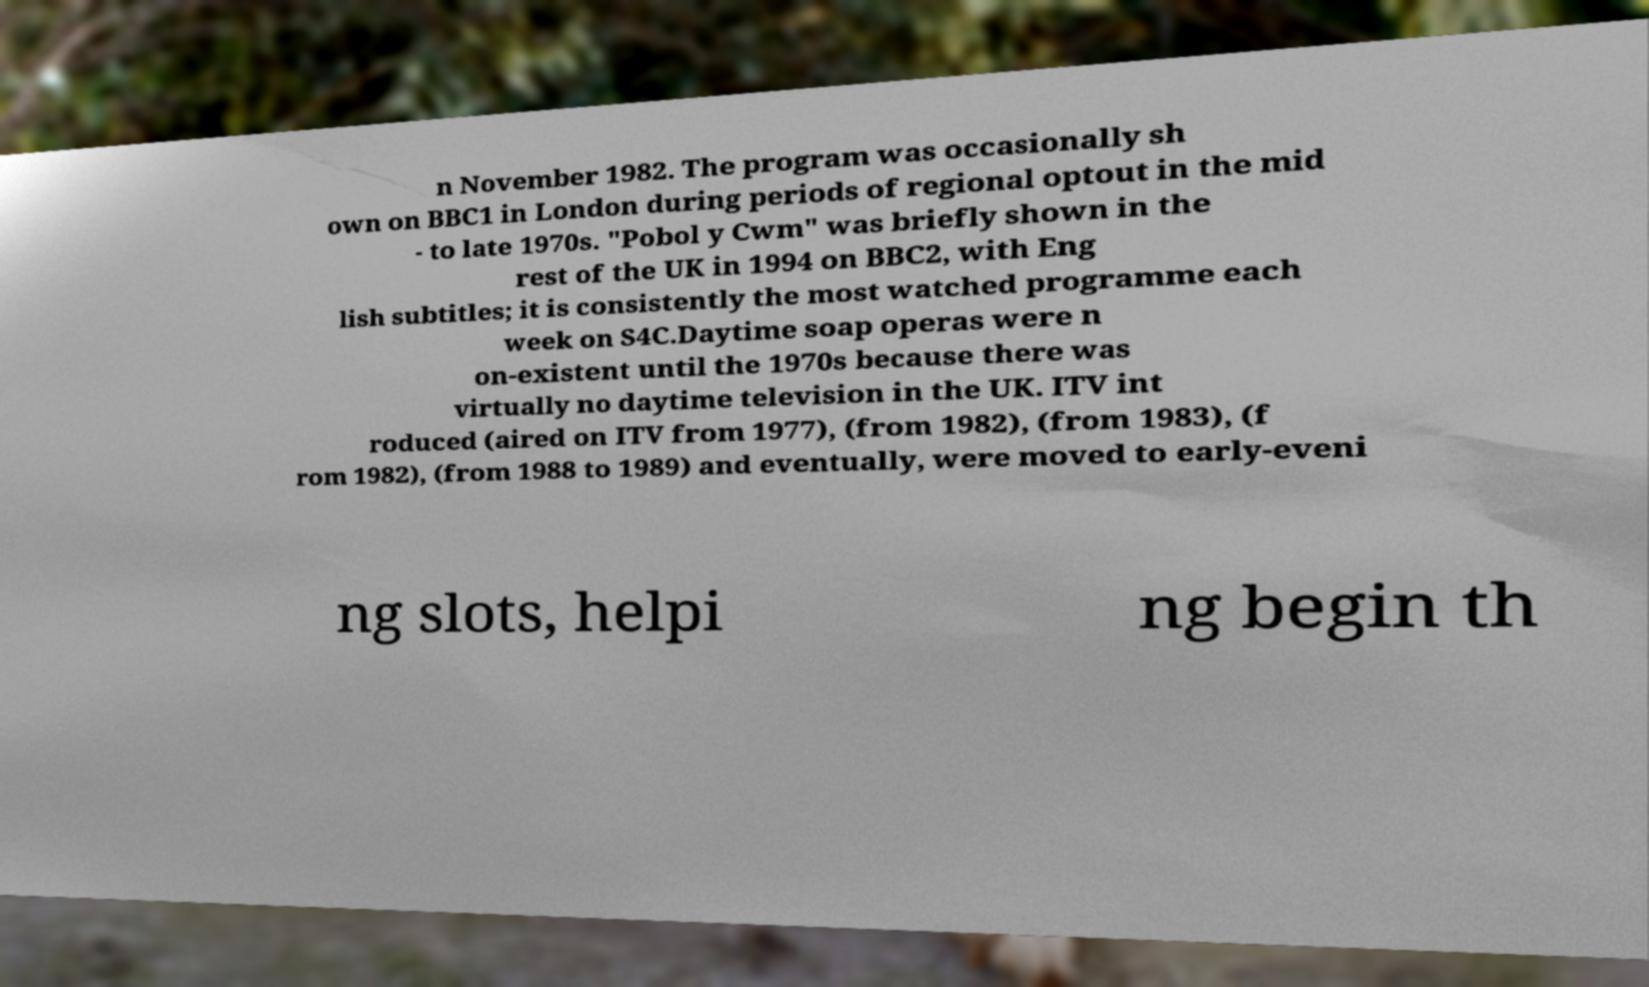Can you read and provide the text displayed in the image?This photo seems to have some interesting text. Can you extract and type it out for me? n November 1982. The program was occasionally sh own on BBC1 in London during periods of regional optout in the mid - to late 1970s. "Pobol y Cwm" was briefly shown in the rest of the UK in 1994 on BBC2, with Eng lish subtitles; it is consistently the most watched programme each week on S4C.Daytime soap operas were n on-existent until the 1970s because there was virtually no daytime television in the UK. ITV int roduced (aired on ITV from 1977), (from 1982), (from 1983), (f rom 1982), (from 1988 to 1989) and eventually, were moved to early-eveni ng slots, helpi ng begin th 